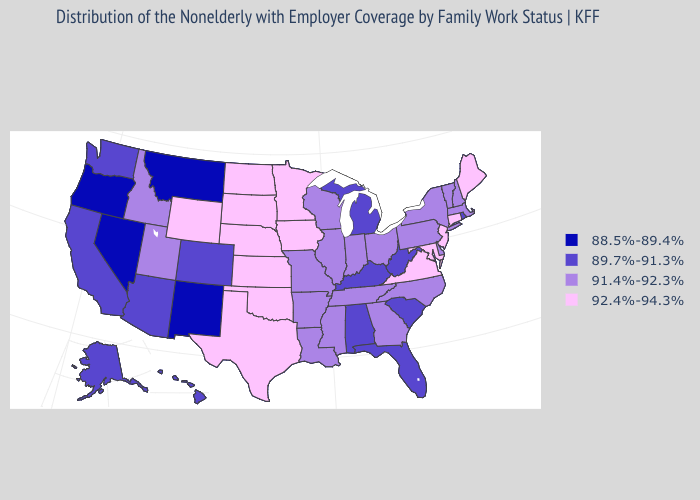Among the states that border Minnesota , which have the highest value?
Give a very brief answer. Iowa, North Dakota, South Dakota. Name the states that have a value in the range 92.4%-94.3%?
Be succinct. Connecticut, Iowa, Kansas, Maine, Maryland, Minnesota, Nebraska, New Jersey, North Dakota, Oklahoma, South Dakota, Texas, Virginia, Wyoming. Among the states that border Washington , which have the highest value?
Give a very brief answer. Idaho. Does North Carolina have the highest value in the USA?
Quick response, please. No. What is the value of North Carolina?
Be succinct. 91.4%-92.3%. Which states have the lowest value in the USA?
Write a very short answer. Montana, Nevada, New Mexico, Oregon. Name the states that have a value in the range 92.4%-94.3%?
Concise answer only. Connecticut, Iowa, Kansas, Maine, Maryland, Minnesota, Nebraska, New Jersey, North Dakota, Oklahoma, South Dakota, Texas, Virginia, Wyoming. Name the states that have a value in the range 89.7%-91.3%?
Give a very brief answer. Alabama, Alaska, Arizona, California, Colorado, Florida, Hawaii, Kentucky, Michigan, Rhode Island, South Carolina, Washington, West Virginia. Does the map have missing data?
Quick response, please. No. Name the states that have a value in the range 89.7%-91.3%?
Concise answer only. Alabama, Alaska, Arizona, California, Colorado, Florida, Hawaii, Kentucky, Michigan, Rhode Island, South Carolina, Washington, West Virginia. Name the states that have a value in the range 88.5%-89.4%?
Quick response, please. Montana, Nevada, New Mexico, Oregon. What is the value of Maine?
Short answer required. 92.4%-94.3%. Which states have the lowest value in the USA?
Be succinct. Montana, Nevada, New Mexico, Oregon. Name the states that have a value in the range 92.4%-94.3%?
Give a very brief answer. Connecticut, Iowa, Kansas, Maine, Maryland, Minnesota, Nebraska, New Jersey, North Dakota, Oklahoma, South Dakota, Texas, Virginia, Wyoming. What is the value of Oklahoma?
Quick response, please. 92.4%-94.3%. 